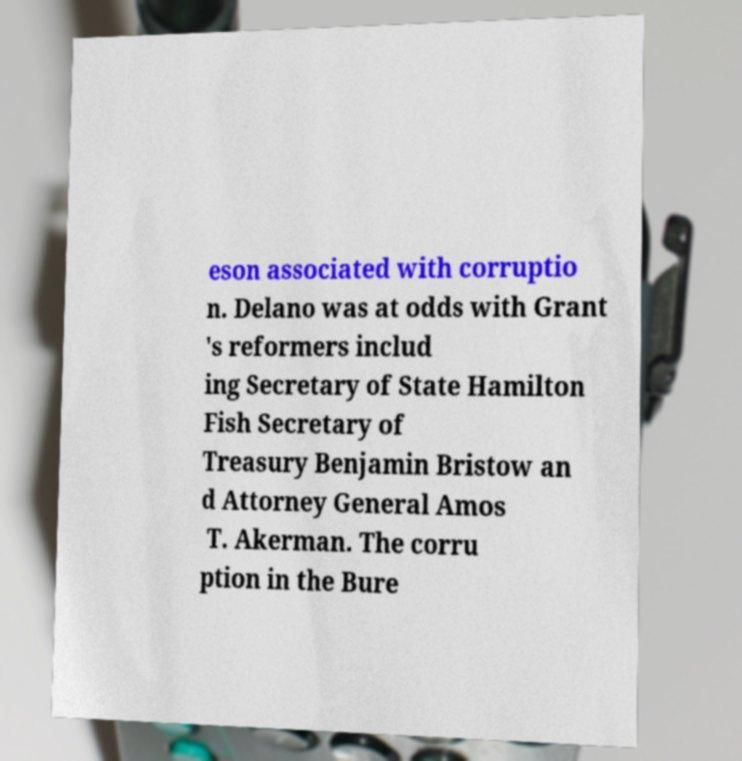Can you read and provide the text displayed in the image?This photo seems to have some interesting text. Can you extract and type it out for me? eson associated with corruptio n. Delano was at odds with Grant 's reformers includ ing Secretary of State Hamilton Fish Secretary of Treasury Benjamin Bristow an d Attorney General Amos T. Akerman. The corru ption in the Bure 